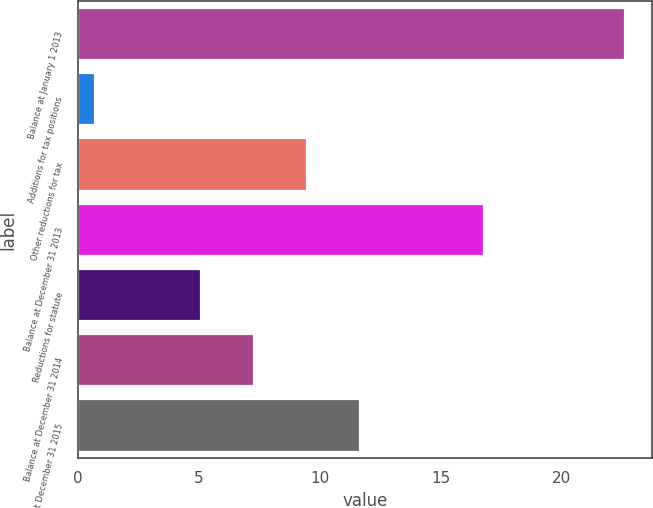Convert chart to OTSL. <chart><loc_0><loc_0><loc_500><loc_500><bar_chart><fcel>Balance at January 1 2013<fcel>Additions for tax positions<fcel>Other reductions for tax<fcel>Balance at December 31 2013<fcel>Reductions for statute<fcel>Balance at December 31 2014<fcel>Balance at December 31 2015<nl><fcel>22.6<fcel>0.7<fcel>9.46<fcel>16.8<fcel>5.08<fcel>7.27<fcel>11.65<nl></chart> 